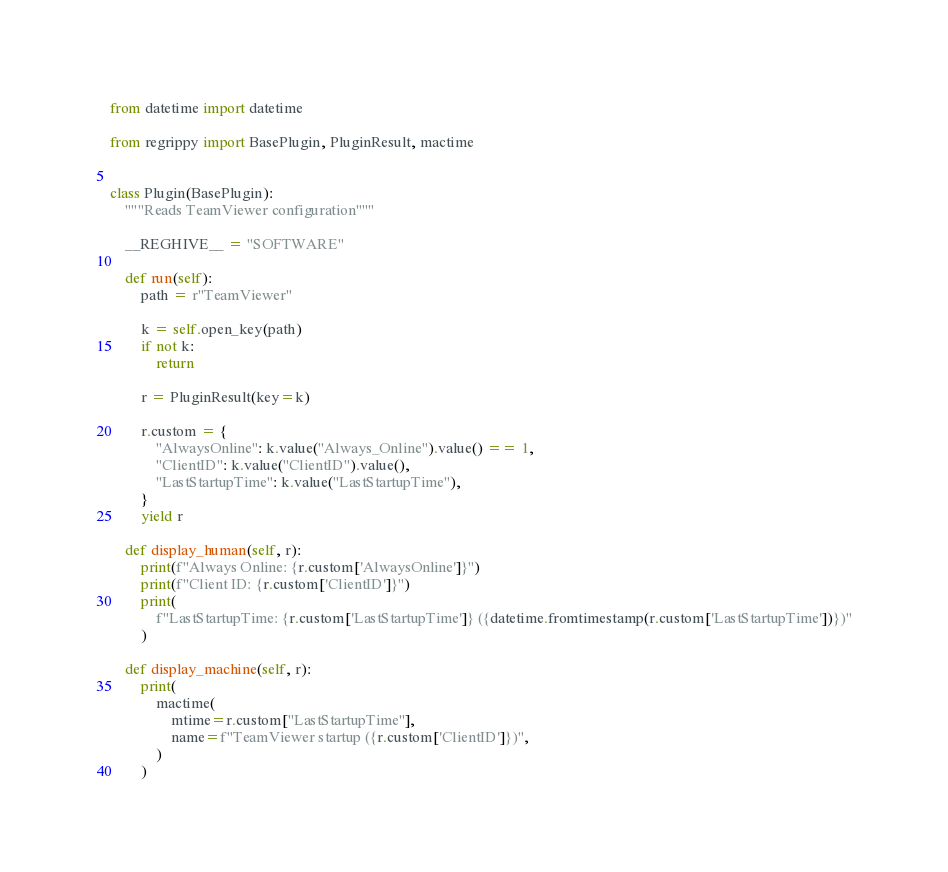Convert code to text. <code><loc_0><loc_0><loc_500><loc_500><_Python_>from datetime import datetime

from regrippy import BasePlugin, PluginResult, mactime


class Plugin(BasePlugin):
    """Reads TeamViewer configuration"""

    __REGHIVE__ = "SOFTWARE"

    def run(self):
        path = r"TeamViewer"

        k = self.open_key(path)
        if not k:
            return

        r = PluginResult(key=k)

        r.custom = {
            "AlwaysOnline": k.value("Always_Online").value() == 1,
            "ClientID": k.value("ClientID").value(),
            "LastStartupTime": k.value("LastStartupTime"),
        }
        yield r

    def display_human(self, r):
        print(f"Always Online: {r.custom['AlwaysOnline']}")
        print(f"Client ID: {r.custom['ClientID']}")
        print(
            f"LastStartupTime: {r.custom['LastStartupTime']} ({datetime.fromtimestamp(r.custom['LastStartupTime'])})"
        )

    def display_machine(self, r):
        print(
            mactime(
                mtime=r.custom["LastStartupTime"],
                name=f"TeamViewer startup ({r.custom['ClientID']})",
            )
        )
</code> 